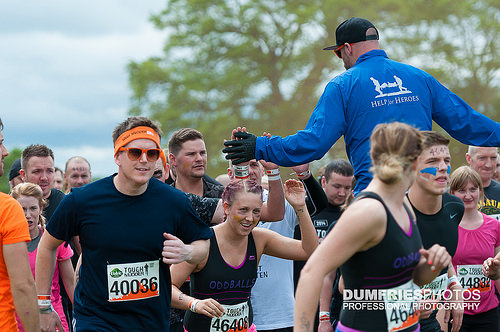<image>
Is there a sky to the right of the tree? No. The sky is not to the right of the tree. The horizontal positioning shows a different relationship. Where is the man in relation to the man? Is it in front of the man? Yes. The man is positioned in front of the man, appearing closer to the camera viewpoint. 